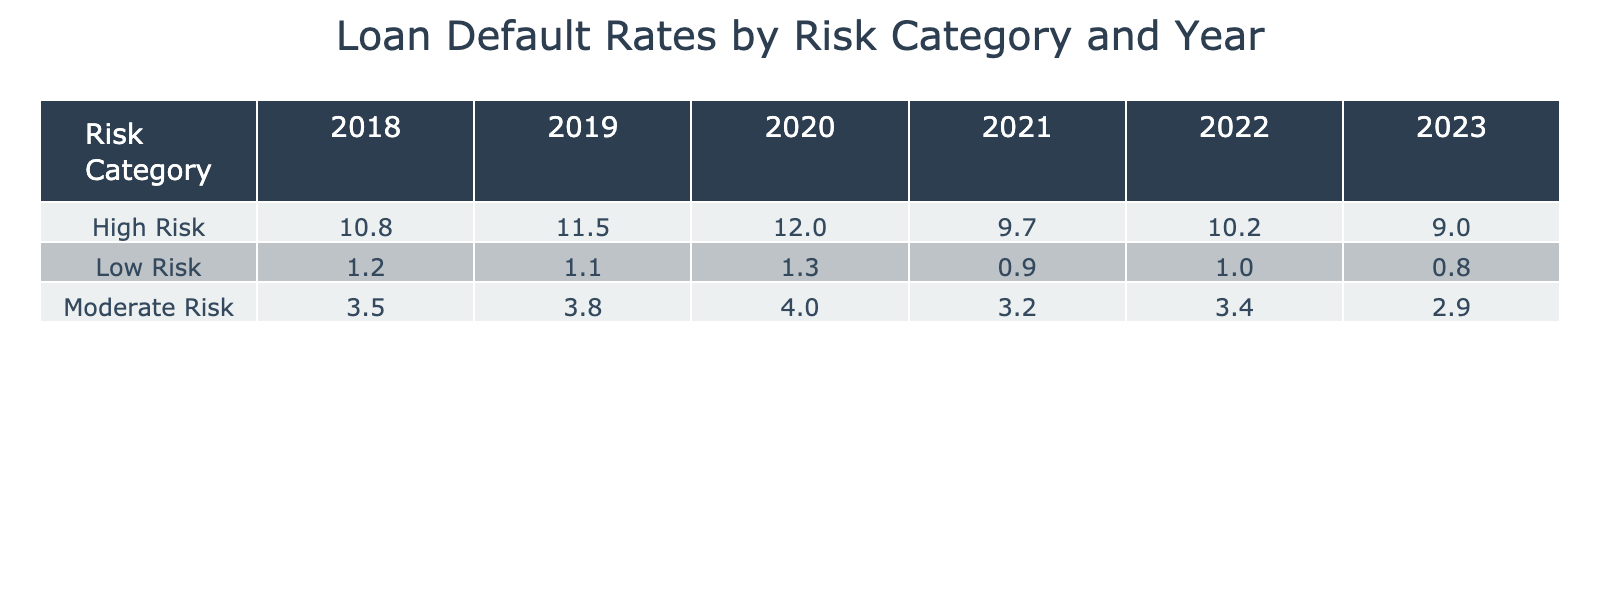What was the loan default rate for High Risk category in 2021? The table shows that for the year 2021, under the High Risk category, the loan default rate is listed as 9.7%.
Answer: 9.7% Which year had the highest loan default rate for Low Risk? Looking through the rows for the Low Risk category, 2020 has the highest rate at 1.3% compared to 1.2% in 2018, 1.1% in 2019, 0.9% in 2021, 1.0% in 2022, and 0.8% in 2023.
Answer: 2020 What is the average loan default rate for Moderate Risk over the years listed? The Moderate Risk values are 3.5%, 3.8%, 4.0%, 3.2%, 3.4%, and 2.9% for the years 2018 to 2023. Adding these gives a total of 21.8%. Dividing by the 6 years results in an average of 3.63%.
Answer: 3.63% Did the loan default rate for High Risk decrease from 2020 to 2023? In 2020, the loan default rate for High Risk was 12.0%, and it decreased to 9.0% in 2023. Since 12.0% is greater than 9.0%, the rate did decrease.
Answer: Yes Which risk category saw the most significant reduction in default rate from 2018 to 2023? Analyzing the data, Low Risk dropped from 1.2% to 0.8% (a reduction of 0.4%), Moderate Risk decreased from 3.5% to 2.9% (a reduction of 0.6%), and High Risk dropped from 10.8% to 9.0% (a reduction of 1.8%). High Risk has the most significant reduction.
Answer: High Risk 